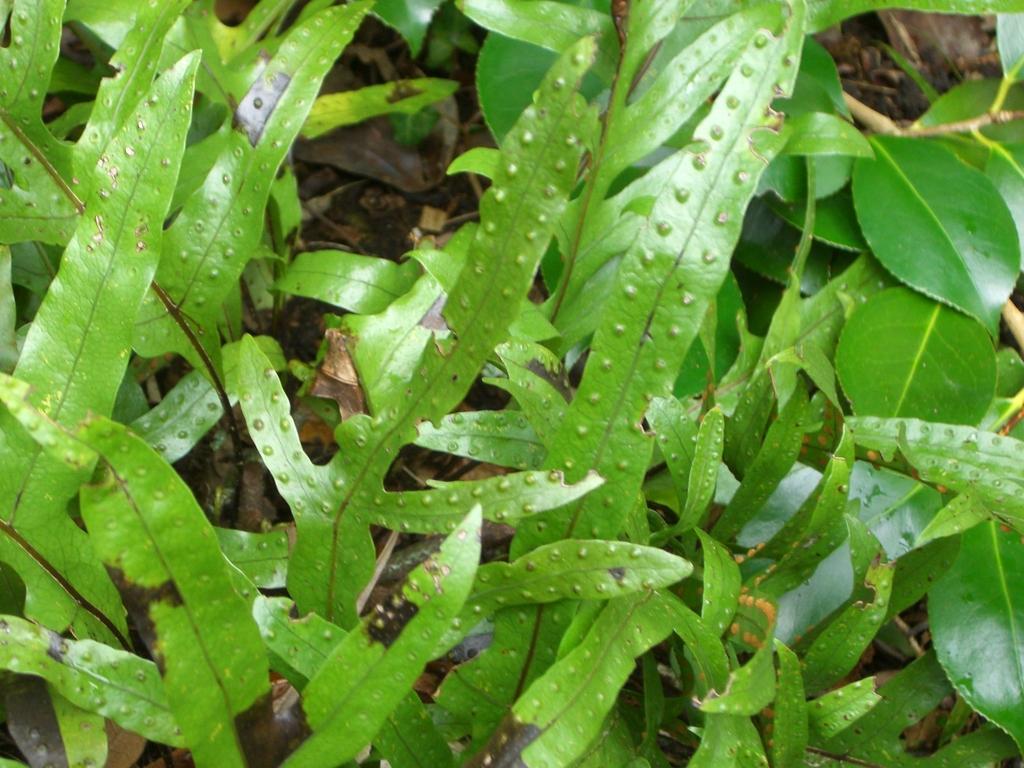Please provide a concise description of this image. In the image there are a lot of leaves. 